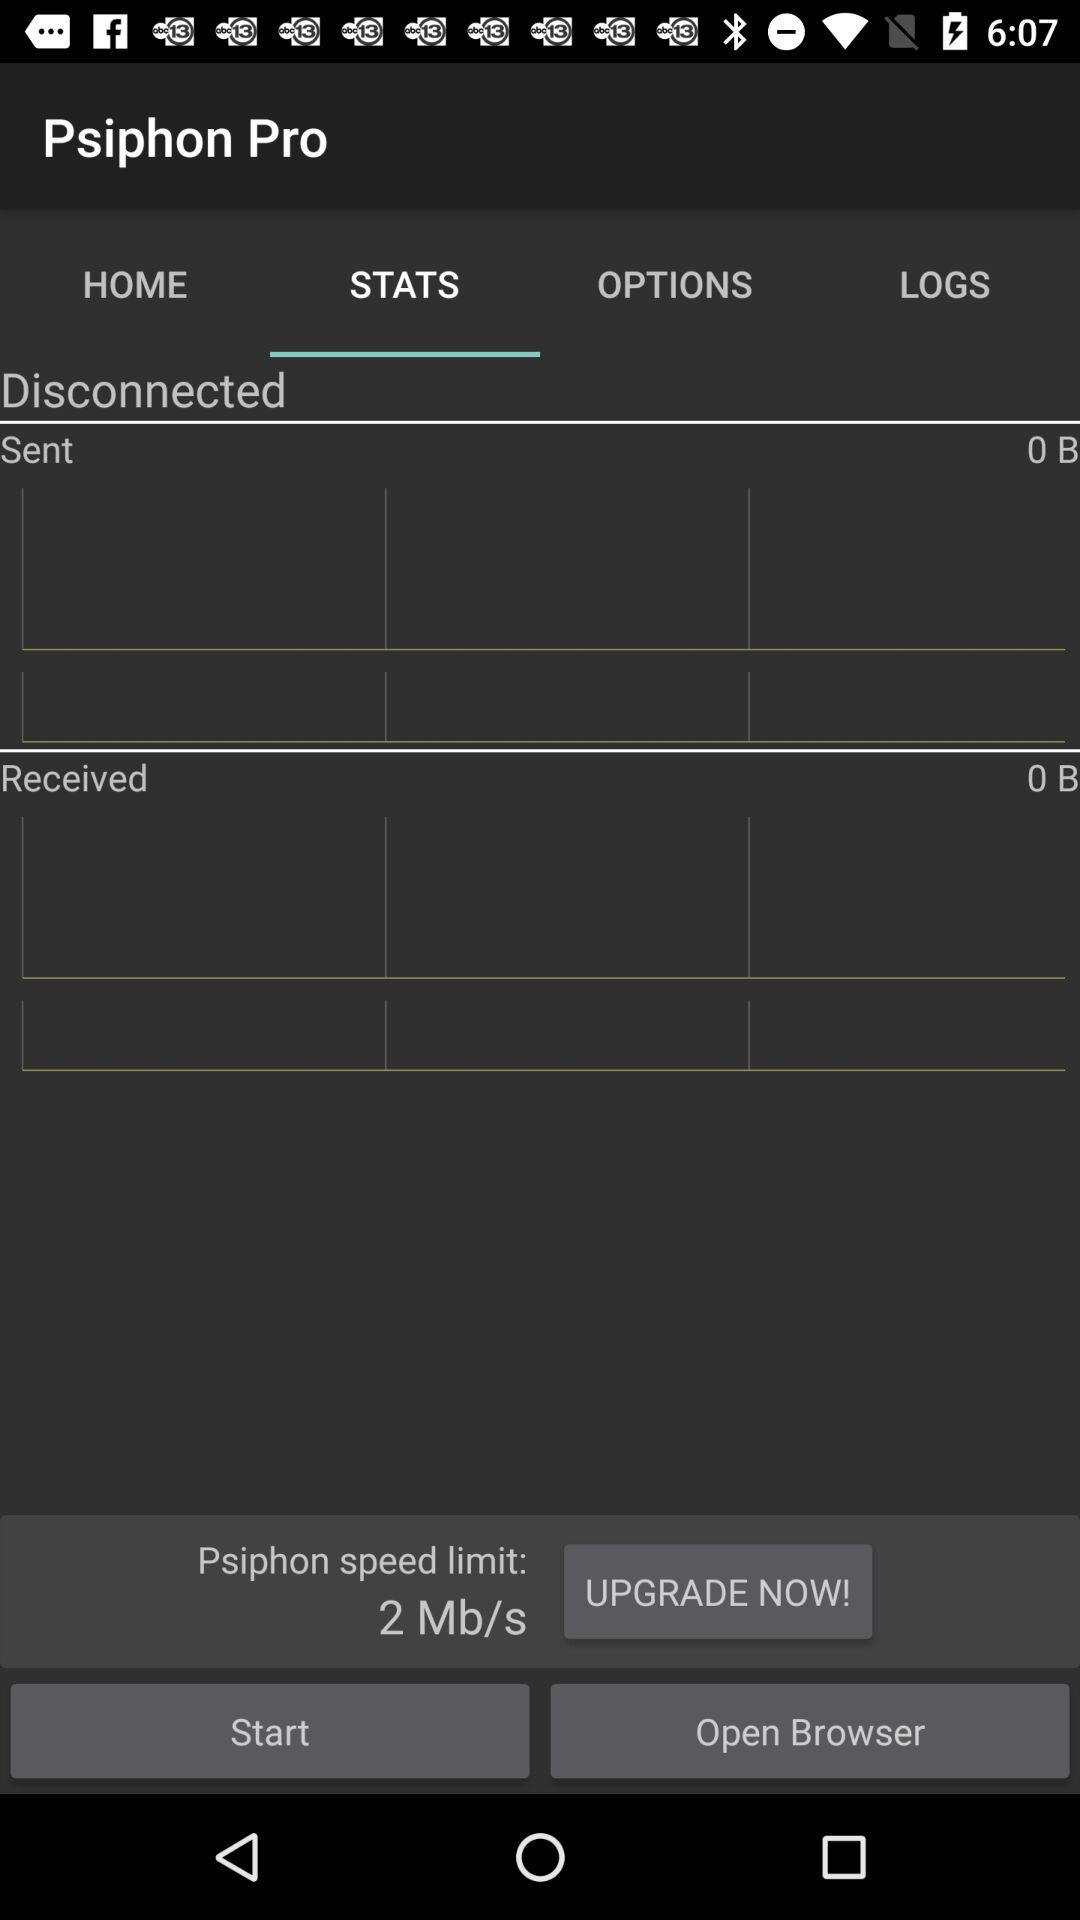What's the psiphon speed limit? The psiphon speed limit is 2 Mb/s. 